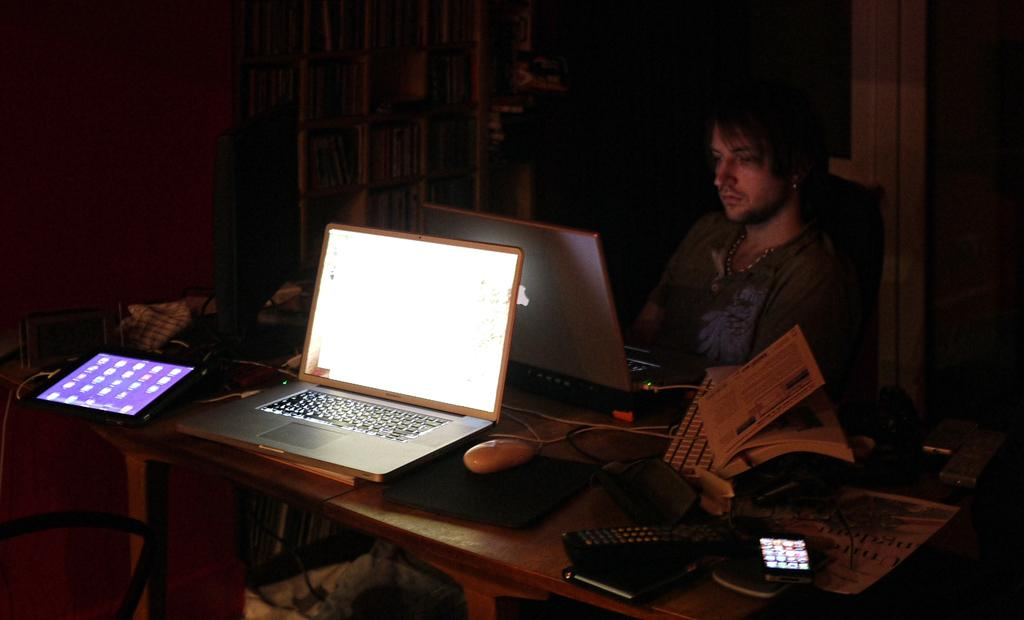What electronic device is being used in the image? There is a laptop in the image that is being operated by a person. What is the person doing with the laptop? The person is operating the laptop. What is the surface on which the laptop is placed? There is a table in the image. What other electronic device is on the table? There is another laptop on the table. What non-electronic items are on the table? There is a tab and some books on the table. What additional item is on the table? There is a cellphone on the table. How many jellyfish are swimming on the ground in the image? There are no jellyfish present in the image, and the ground is not visible in the image. What is the person reading on the laptop? The provided facts do not mention any reading material on the laptop, so we cannot determine what the person is reading. 